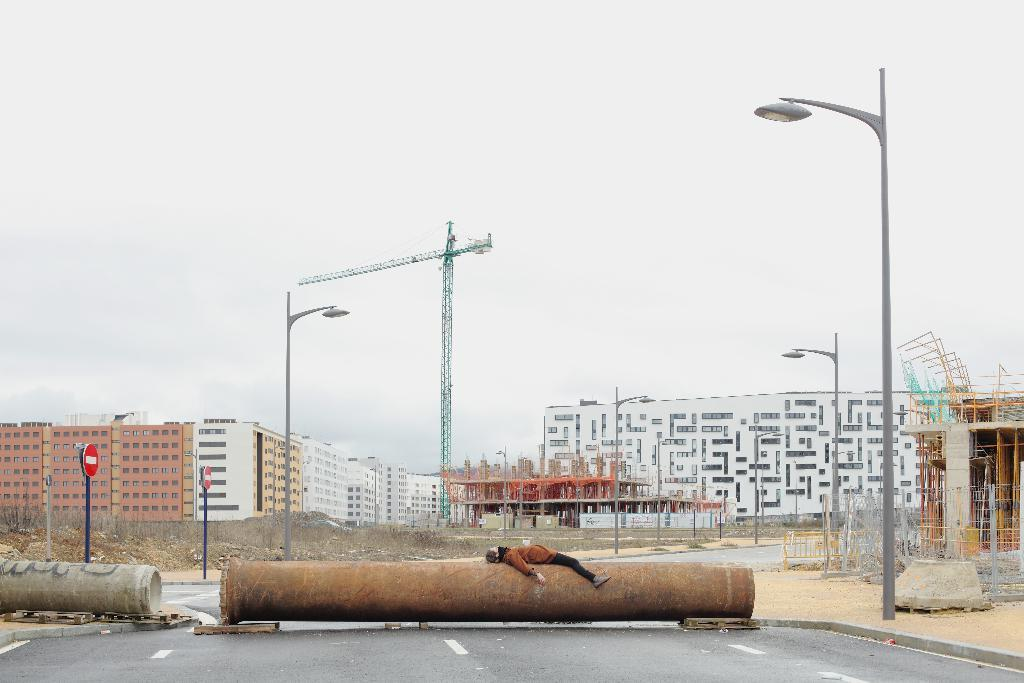What is the main object in the center of the image? There is a pole in the center of the image. What is happening with the person in the image? The person is lying on the pole. What can be seen in the distance behind the pole? There are buildings in the background of the image. What type of net is being used to catch the bears in the image? There are no bears or nets present in the image; it features a pole with a person lying on it and buildings in the background. 